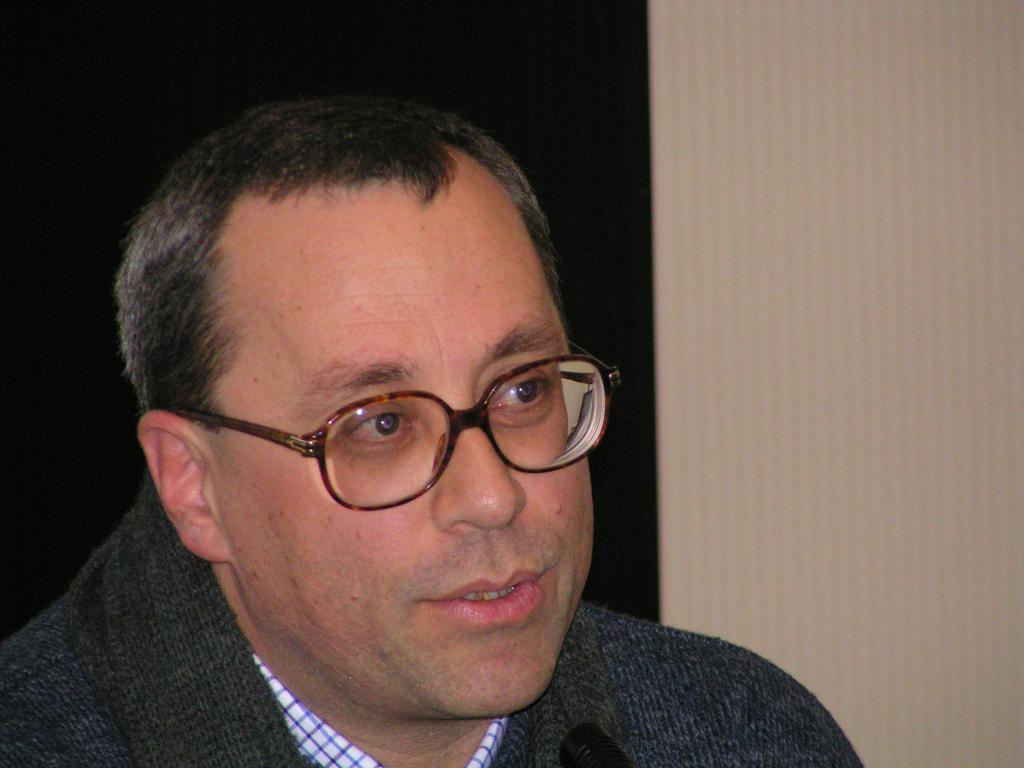What is the main subject of the image? There is a person in the image. What is the color scheme of the background in the image? The background of the image is black and white. What type of flower is being distributed by the person in the image? There is no flower present in the image, and the person is not distributing anything. What is the person wearing on their wrist in the image? There is no information about the person's wrist or any accessories they might be wearing in the image. 